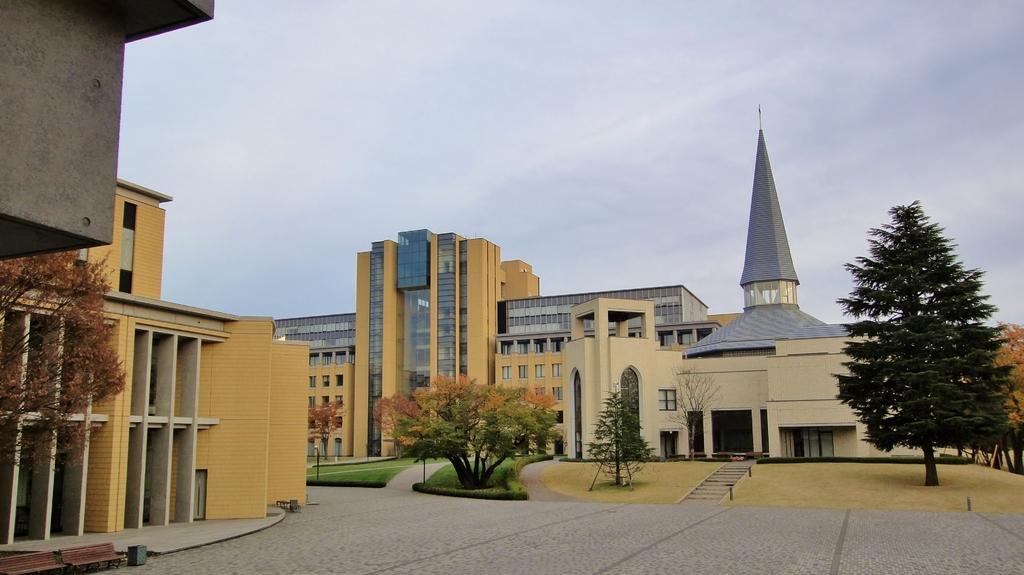How would you summarize this image in a sentence or two? In the image there are buildings in the back with many trees and garden in front of it and above its sky with clouds. 